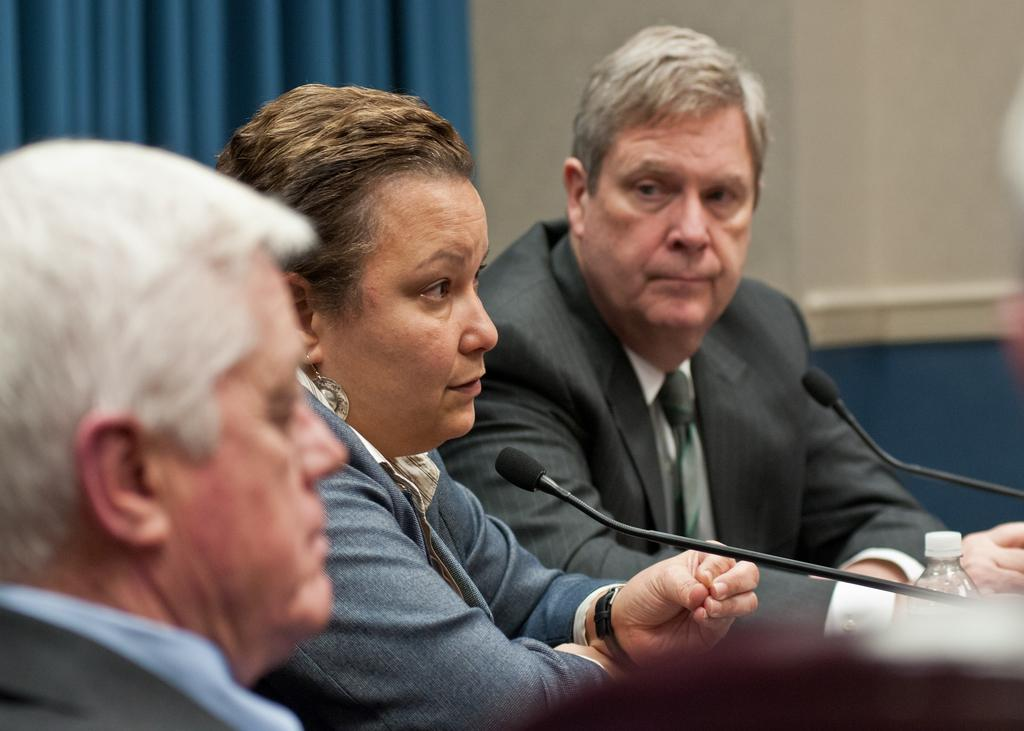How many people are in the image? There are three people in the center of the image. What can be seen in the background of the image? There is a wall in the background of the image. How many books are on the shelf in the image? There is no shelf or books present in the image. What type of twig can be seen in the hands of one of the people in the image? There is no twig present in the image; only the three people and the wall are visible. 